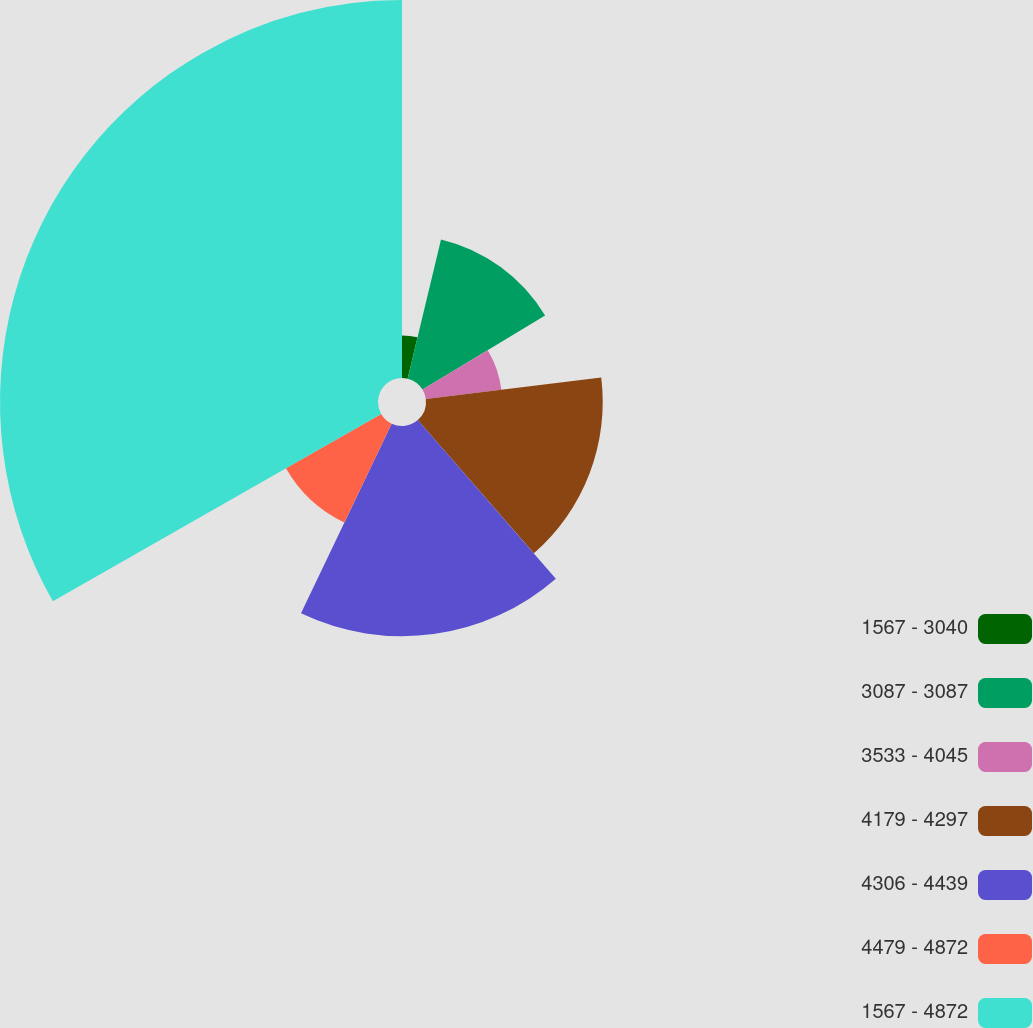<chart> <loc_0><loc_0><loc_500><loc_500><pie_chart><fcel>1567 - 3040<fcel>3087 - 3087<fcel>3533 - 4045<fcel>4179 - 4297<fcel>4306 - 4439<fcel>4479 - 4872<fcel>1567 - 4872<nl><fcel>3.75%<fcel>12.6%<fcel>6.7%<fcel>15.55%<fcel>18.5%<fcel>9.65%<fcel>33.26%<nl></chart> 